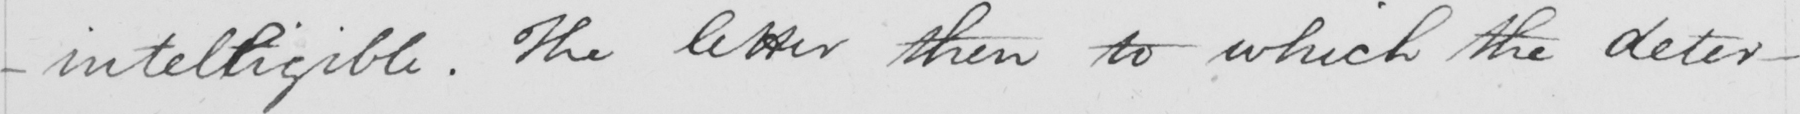Please transcribe the handwritten text in this image. -intelligible . The letter then to which the deter- 